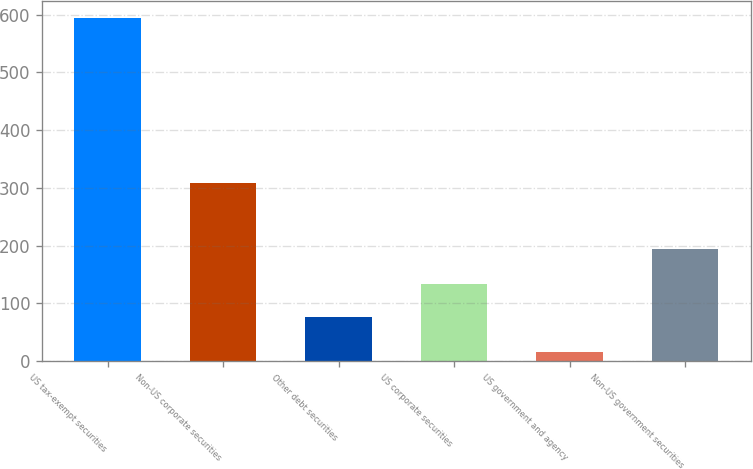<chart> <loc_0><loc_0><loc_500><loc_500><bar_chart><fcel>US tax-exempt securities<fcel>Non-US corporate securities<fcel>Other debt securities<fcel>US corporate securities<fcel>US government and agency<fcel>Non-US government securities<nl><fcel>595<fcel>308<fcel>75.9<fcel>133.83<fcel>15.7<fcel>193.7<nl></chart> 